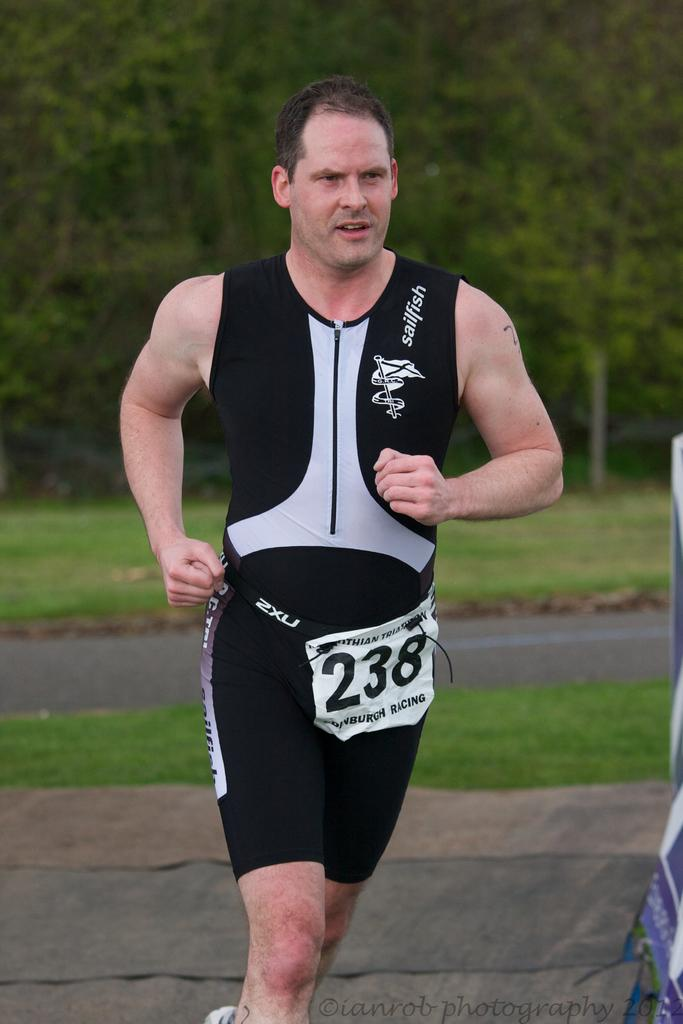<image>
Share a concise interpretation of the image provided. A runner with the participant bib number 238. 